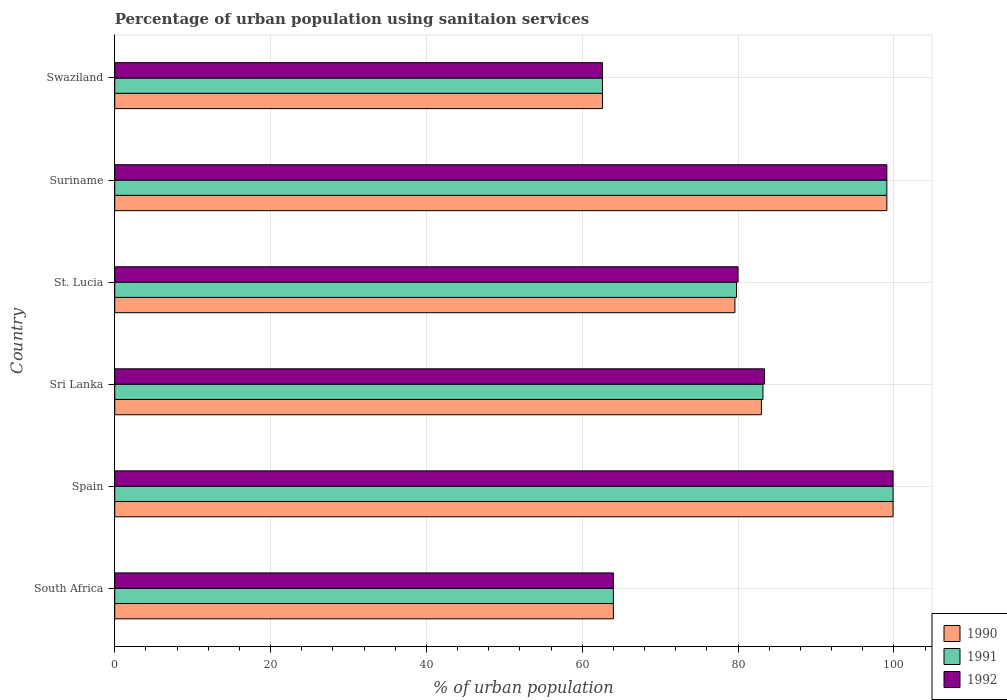How many different coloured bars are there?
Offer a very short reply. 3. Are the number of bars on each tick of the Y-axis equal?
Keep it short and to the point. Yes. What is the label of the 3rd group of bars from the top?
Provide a short and direct response. St. Lucia. What is the percentage of urban population using sanitaion services in 1991 in Suriname?
Your answer should be very brief. 99.1. Across all countries, what is the maximum percentage of urban population using sanitaion services in 1991?
Make the answer very short. 99.9. Across all countries, what is the minimum percentage of urban population using sanitaion services in 1991?
Your answer should be very brief. 62.6. In which country was the percentage of urban population using sanitaion services in 1992 minimum?
Give a very brief answer. Swaziland. What is the total percentage of urban population using sanitaion services in 1992 in the graph?
Offer a terse response. 489. What is the difference between the percentage of urban population using sanitaion services in 1990 in Spain and that in Sri Lanka?
Provide a short and direct response. 16.9. What is the difference between the percentage of urban population using sanitaion services in 1990 in Sri Lanka and the percentage of urban population using sanitaion services in 1992 in Spain?
Offer a very short reply. -16.9. What is the average percentage of urban population using sanitaion services in 1990 per country?
Offer a very short reply. 81.37. What is the difference between the percentage of urban population using sanitaion services in 1992 and percentage of urban population using sanitaion services in 1991 in Swaziland?
Offer a very short reply. 0. In how many countries, is the percentage of urban population using sanitaion services in 1991 greater than 44 %?
Make the answer very short. 6. What is the ratio of the percentage of urban population using sanitaion services in 1991 in South Africa to that in St. Lucia?
Your answer should be compact. 0.8. Is the percentage of urban population using sanitaion services in 1992 in Spain less than that in Suriname?
Your answer should be compact. No. Is the difference between the percentage of urban population using sanitaion services in 1992 in Suriname and Swaziland greater than the difference between the percentage of urban population using sanitaion services in 1991 in Suriname and Swaziland?
Your answer should be compact. No. What is the difference between the highest and the second highest percentage of urban population using sanitaion services in 1991?
Your answer should be very brief. 0.8. What is the difference between the highest and the lowest percentage of urban population using sanitaion services in 1992?
Ensure brevity in your answer.  37.3. Is the sum of the percentage of urban population using sanitaion services in 1990 in St. Lucia and Swaziland greater than the maximum percentage of urban population using sanitaion services in 1991 across all countries?
Provide a short and direct response. Yes. Are all the bars in the graph horizontal?
Your response must be concise. Yes. How many countries are there in the graph?
Make the answer very short. 6. Does the graph contain grids?
Provide a short and direct response. Yes. Where does the legend appear in the graph?
Keep it short and to the point. Bottom right. How are the legend labels stacked?
Give a very brief answer. Vertical. What is the title of the graph?
Keep it short and to the point. Percentage of urban population using sanitaion services. What is the label or title of the X-axis?
Your answer should be very brief. % of urban population. What is the label or title of the Y-axis?
Provide a short and direct response. Country. What is the % of urban population in 1990 in South Africa?
Keep it short and to the point. 64. What is the % of urban population in 1990 in Spain?
Ensure brevity in your answer.  99.9. What is the % of urban population in 1991 in Spain?
Your answer should be compact. 99.9. What is the % of urban population of 1992 in Spain?
Your response must be concise. 99.9. What is the % of urban population of 1990 in Sri Lanka?
Provide a short and direct response. 83. What is the % of urban population of 1991 in Sri Lanka?
Make the answer very short. 83.2. What is the % of urban population in 1992 in Sri Lanka?
Provide a succinct answer. 83.4. What is the % of urban population in 1990 in St. Lucia?
Provide a succinct answer. 79.6. What is the % of urban population in 1991 in St. Lucia?
Make the answer very short. 79.8. What is the % of urban population in 1992 in St. Lucia?
Your answer should be very brief. 80. What is the % of urban population in 1990 in Suriname?
Offer a terse response. 99.1. What is the % of urban population in 1991 in Suriname?
Keep it short and to the point. 99.1. What is the % of urban population in 1992 in Suriname?
Provide a short and direct response. 99.1. What is the % of urban population in 1990 in Swaziland?
Make the answer very short. 62.6. What is the % of urban population in 1991 in Swaziland?
Offer a terse response. 62.6. What is the % of urban population of 1992 in Swaziland?
Offer a terse response. 62.6. Across all countries, what is the maximum % of urban population of 1990?
Provide a succinct answer. 99.9. Across all countries, what is the maximum % of urban population of 1991?
Provide a succinct answer. 99.9. Across all countries, what is the maximum % of urban population in 1992?
Provide a succinct answer. 99.9. Across all countries, what is the minimum % of urban population in 1990?
Offer a terse response. 62.6. Across all countries, what is the minimum % of urban population in 1991?
Your answer should be compact. 62.6. Across all countries, what is the minimum % of urban population in 1992?
Your answer should be compact. 62.6. What is the total % of urban population in 1990 in the graph?
Give a very brief answer. 488.2. What is the total % of urban population in 1991 in the graph?
Ensure brevity in your answer.  488.6. What is the total % of urban population of 1992 in the graph?
Provide a succinct answer. 489. What is the difference between the % of urban population of 1990 in South Africa and that in Spain?
Provide a short and direct response. -35.9. What is the difference between the % of urban population of 1991 in South Africa and that in Spain?
Give a very brief answer. -35.9. What is the difference between the % of urban population in 1992 in South Africa and that in Spain?
Your answer should be compact. -35.9. What is the difference between the % of urban population in 1991 in South Africa and that in Sri Lanka?
Your answer should be very brief. -19.2. What is the difference between the % of urban population of 1992 in South Africa and that in Sri Lanka?
Make the answer very short. -19.4. What is the difference between the % of urban population in 1990 in South Africa and that in St. Lucia?
Make the answer very short. -15.6. What is the difference between the % of urban population in 1991 in South Africa and that in St. Lucia?
Your answer should be very brief. -15.8. What is the difference between the % of urban population of 1990 in South Africa and that in Suriname?
Offer a very short reply. -35.1. What is the difference between the % of urban population in 1991 in South Africa and that in Suriname?
Keep it short and to the point. -35.1. What is the difference between the % of urban population of 1992 in South Africa and that in Suriname?
Offer a terse response. -35.1. What is the difference between the % of urban population of 1990 in South Africa and that in Swaziland?
Offer a terse response. 1.4. What is the difference between the % of urban population of 1991 in South Africa and that in Swaziland?
Keep it short and to the point. 1.4. What is the difference between the % of urban population in 1991 in Spain and that in Sri Lanka?
Ensure brevity in your answer.  16.7. What is the difference between the % of urban population in 1990 in Spain and that in St. Lucia?
Your answer should be compact. 20.3. What is the difference between the % of urban population of 1991 in Spain and that in St. Lucia?
Keep it short and to the point. 20.1. What is the difference between the % of urban population in 1992 in Spain and that in St. Lucia?
Offer a very short reply. 19.9. What is the difference between the % of urban population of 1991 in Spain and that in Suriname?
Keep it short and to the point. 0.8. What is the difference between the % of urban population of 1992 in Spain and that in Suriname?
Give a very brief answer. 0.8. What is the difference between the % of urban population in 1990 in Spain and that in Swaziland?
Offer a terse response. 37.3. What is the difference between the % of urban population in 1991 in Spain and that in Swaziland?
Your answer should be compact. 37.3. What is the difference between the % of urban population of 1992 in Spain and that in Swaziland?
Give a very brief answer. 37.3. What is the difference between the % of urban population in 1992 in Sri Lanka and that in St. Lucia?
Provide a short and direct response. 3.4. What is the difference between the % of urban population in 1990 in Sri Lanka and that in Suriname?
Provide a succinct answer. -16.1. What is the difference between the % of urban population in 1991 in Sri Lanka and that in Suriname?
Provide a succinct answer. -15.9. What is the difference between the % of urban population in 1992 in Sri Lanka and that in Suriname?
Offer a very short reply. -15.7. What is the difference between the % of urban population in 1990 in Sri Lanka and that in Swaziland?
Offer a very short reply. 20.4. What is the difference between the % of urban population in 1991 in Sri Lanka and that in Swaziland?
Give a very brief answer. 20.6. What is the difference between the % of urban population in 1992 in Sri Lanka and that in Swaziland?
Make the answer very short. 20.8. What is the difference between the % of urban population in 1990 in St. Lucia and that in Suriname?
Keep it short and to the point. -19.5. What is the difference between the % of urban population in 1991 in St. Lucia and that in Suriname?
Provide a short and direct response. -19.3. What is the difference between the % of urban population in 1992 in St. Lucia and that in Suriname?
Your answer should be very brief. -19.1. What is the difference between the % of urban population in 1990 in St. Lucia and that in Swaziland?
Your answer should be compact. 17. What is the difference between the % of urban population in 1991 in St. Lucia and that in Swaziland?
Provide a succinct answer. 17.2. What is the difference between the % of urban population of 1990 in Suriname and that in Swaziland?
Your response must be concise. 36.5. What is the difference between the % of urban population in 1991 in Suriname and that in Swaziland?
Provide a short and direct response. 36.5. What is the difference between the % of urban population in 1992 in Suriname and that in Swaziland?
Your answer should be very brief. 36.5. What is the difference between the % of urban population in 1990 in South Africa and the % of urban population in 1991 in Spain?
Provide a short and direct response. -35.9. What is the difference between the % of urban population of 1990 in South Africa and the % of urban population of 1992 in Spain?
Give a very brief answer. -35.9. What is the difference between the % of urban population in 1991 in South Africa and the % of urban population in 1992 in Spain?
Ensure brevity in your answer.  -35.9. What is the difference between the % of urban population of 1990 in South Africa and the % of urban population of 1991 in Sri Lanka?
Offer a terse response. -19.2. What is the difference between the % of urban population of 1990 in South Africa and the % of urban population of 1992 in Sri Lanka?
Your response must be concise. -19.4. What is the difference between the % of urban population in 1991 in South Africa and the % of urban population in 1992 in Sri Lanka?
Ensure brevity in your answer.  -19.4. What is the difference between the % of urban population of 1990 in South Africa and the % of urban population of 1991 in St. Lucia?
Give a very brief answer. -15.8. What is the difference between the % of urban population of 1990 in South Africa and the % of urban population of 1992 in St. Lucia?
Provide a succinct answer. -16. What is the difference between the % of urban population in 1991 in South Africa and the % of urban population in 1992 in St. Lucia?
Keep it short and to the point. -16. What is the difference between the % of urban population of 1990 in South Africa and the % of urban population of 1991 in Suriname?
Ensure brevity in your answer.  -35.1. What is the difference between the % of urban population in 1990 in South Africa and the % of urban population in 1992 in Suriname?
Give a very brief answer. -35.1. What is the difference between the % of urban population in 1991 in South Africa and the % of urban population in 1992 in Suriname?
Your response must be concise. -35.1. What is the difference between the % of urban population in 1990 in South Africa and the % of urban population in 1991 in Swaziland?
Provide a succinct answer. 1.4. What is the difference between the % of urban population in 1991 in South Africa and the % of urban population in 1992 in Swaziland?
Keep it short and to the point. 1.4. What is the difference between the % of urban population of 1990 in Spain and the % of urban population of 1991 in Sri Lanka?
Make the answer very short. 16.7. What is the difference between the % of urban population in 1990 in Spain and the % of urban population in 1992 in Sri Lanka?
Provide a short and direct response. 16.5. What is the difference between the % of urban population of 1990 in Spain and the % of urban population of 1991 in St. Lucia?
Keep it short and to the point. 20.1. What is the difference between the % of urban population of 1990 in Spain and the % of urban population of 1991 in Suriname?
Offer a terse response. 0.8. What is the difference between the % of urban population of 1990 in Spain and the % of urban population of 1991 in Swaziland?
Make the answer very short. 37.3. What is the difference between the % of urban population in 1990 in Spain and the % of urban population in 1992 in Swaziland?
Your answer should be very brief. 37.3. What is the difference between the % of urban population of 1991 in Spain and the % of urban population of 1992 in Swaziland?
Your response must be concise. 37.3. What is the difference between the % of urban population of 1990 in Sri Lanka and the % of urban population of 1991 in St. Lucia?
Your answer should be compact. 3.2. What is the difference between the % of urban population in 1991 in Sri Lanka and the % of urban population in 1992 in St. Lucia?
Give a very brief answer. 3.2. What is the difference between the % of urban population of 1990 in Sri Lanka and the % of urban population of 1991 in Suriname?
Give a very brief answer. -16.1. What is the difference between the % of urban population of 1990 in Sri Lanka and the % of urban population of 1992 in Suriname?
Make the answer very short. -16.1. What is the difference between the % of urban population in 1991 in Sri Lanka and the % of urban population in 1992 in Suriname?
Offer a terse response. -15.9. What is the difference between the % of urban population in 1990 in Sri Lanka and the % of urban population in 1991 in Swaziland?
Make the answer very short. 20.4. What is the difference between the % of urban population in 1990 in Sri Lanka and the % of urban population in 1992 in Swaziland?
Make the answer very short. 20.4. What is the difference between the % of urban population of 1991 in Sri Lanka and the % of urban population of 1992 in Swaziland?
Provide a succinct answer. 20.6. What is the difference between the % of urban population of 1990 in St. Lucia and the % of urban population of 1991 in Suriname?
Give a very brief answer. -19.5. What is the difference between the % of urban population of 1990 in St. Lucia and the % of urban population of 1992 in Suriname?
Provide a short and direct response. -19.5. What is the difference between the % of urban population of 1991 in St. Lucia and the % of urban population of 1992 in Suriname?
Make the answer very short. -19.3. What is the difference between the % of urban population of 1990 in St. Lucia and the % of urban population of 1991 in Swaziland?
Offer a very short reply. 17. What is the difference between the % of urban population in 1991 in St. Lucia and the % of urban population in 1992 in Swaziland?
Make the answer very short. 17.2. What is the difference between the % of urban population in 1990 in Suriname and the % of urban population in 1991 in Swaziland?
Offer a very short reply. 36.5. What is the difference between the % of urban population of 1990 in Suriname and the % of urban population of 1992 in Swaziland?
Provide a short and direct response. 36.5. What is the difference between the % of urban population in 1991 in Suriname and the % of urban population in 1992 in Swaziland?
Ensure brevity in your answer.  36.5. What is the average % of urban population in 1990 per country?
Make the answer very short. 81.37. What is the average % of urban population of 1991 per country?
Your response must be concise. 81.43. What is the average % of urban population in 1992 per country?
Provide a short and direct response. 81.5. What is the difference between the % of urban population of 1990 and % of urban population of 1992 in South Africa?
Provide a succinct answer. 0. What is the difference between the % of urban population of 1991 and % of urban population of 1992 in South Africa?
Provide a succinct answer. 0. What is the difference between the % of urban population of 1990 and % of urban population of 1991 in Spain?
Offer a terse response. 0. What is the difference between the % of urban population of 1991 and % of urban population of 1992 in Spain?
Offer a very short reply. 0. What is the difference between the % of urban population of 1990 and % of urban population of 1991 in Sri Lanka?
Provide a short and direct response. -0.2. What is the difference between the % of urban population in 1990 and % of urban population in 1991 in St. Lucia?
Offer a terse response. -0.2. What is the difference between the % of urban population in 1990 and % of urban population in 1992 in St. Lucia?
Give a very brief answer. -0.4. What is the difference between the % of urban population of 1990 and % of urban population of 1992 in Suriname?
Your answer should be compact. 0. What is the difference between the % of urban population of 1991 and % of urban population of 1992 in Swaziland?
Make the answer very short. 0. What is the ratio of the % of urban population of 1990 in South Africa to that in Spain?
Offer a terse response. 0.64. What is the ratio of the % of urban population of 1991 in South Africa to that in Spain?
Provide a succinct answer. 0.64. What is the ratio of the % of urban population in 1992 in South Africa to that in Spain?
Your answer should be compact. 0.64. What is the ratio of the % of urban population of 1990 in South Africa to that in Sri Lanka?
Keep it short and to the point. 0.77. What is the ratio of the % of urban population in 1991 in South Africa to that in Sri Lanka?
Provide a succinct answer. 0.77. What is the ratio of the % of urban population in 1992 in South Africa to that in Sri Lanka?
Keep it short and to the point. 0.77. What is the ratio of the % of urban population in 1990 in South Africa to that in St. Lucia?
Provide a succinct answer. 0.8. What is the ratio of the % of urban population of 1991 in South Africa to that in St. Lucia?
Your response must be concise. 0.8. What is the ratio of the % of urban population of 1992 in South Africa to that in St. Lucia?
Make the answer very short. 0.8. What is the ratio of the % of urban population of 1990 in South Africa to that in Suriname?
Your answer should be very brief. 0.65. What is the ratio of the % of urban population of 1991 in South Africa to that in Suriname?
Your answer should be very brief. 0.65. What is the ratio of the % of urban population of 1992 in South Africa to that in Suriname?
Your answer should be compact. 0.65. What is the ratio of the % of urban population of 1990 in South Africa to that in Swaziland?
Make the answer very short. 1.02. What is the ratio of the % of urban population of 1991 in South Africa to that in Swaziland?
Offer a very short reply. 1.02. What is the ratio of the % of urban population in 1992 in South Africa to that in Swaziland?
Offer a terse response. 1.02. What is the ratio of the % of urban population in 1990 in Spain to that in Sri Lanka?
Keep it short and to the point. 1.2. What is the ratio of the % of urban population of 1991 in Spain to that in Sri Lanka?
Give a very brief answer. 1.2. What is the ratio of the % of urban population of 1992 in Spain to that in Sri Lanka?
Provide a short and direct response. 1.2. What is the ratio of the % of urban population of 1990 in Spain to that in St. Lucia?
Ensure brevity in your answer.  1.25. What is the ratio of the % of urban population in 1991 in Spain to that in St. Lucia?
Your response must be concise. 1.25. What is the ratio of the % of urban population of 1992 in Spain to that in St. Lucia?
Provide a succinct answer. 1.25. What is the ratio of the % of urban population in 1990 in Spain to that in Swaziland?
Keep it short and to the point. 1.6. What is the ratio of the % of urban population of 1991 in Spain to that in Swaziland?
Your response must be concise. 1.6. What is the ratio of the % of urban population in 1992 in Spain to that in Swaziland?
Keep it short and to the point. 1.6. What is the ratio of the % of urban population of 1990 in Sri Lanka to that in St. Lucia?
Offer a terse response. 1.04. What is the ratio of the % of urban population of 1991 in Sri Lanka to that in St. Lucia?
Offer a terse response. 1.04. What is the ratio of the % of urban population in 1992 in Sri Lanka to that in St. Lucia?
Ensure brevity in your answer.  1.04. What is the ratio of the % of urban population in 1990 in Sri Lanka to that in Suriname?
Give a very brief answer. 0.84. What is the ratio of the % of urban population of 1991 in Sri Lanka to that in Suriname?
Offer a terse response. 0.84. What is the ratio of the % of urban population of 1992 in Sri Lanka to that in Suriname?
Keep it short and to the point. 0.84. What is the ratio of the % of urban population in 1990 in Sri Lanka to that in Swaziland?
Ensure brevity in your answer.  1.33. What is the ratio of the % of urban population in 1991 in Sri Lanka to that in Swaziland?
Offer a very short reply. 1.33. What is the ratio of the % of urban population of 1992 in Sri Lanka to that in Swaziland?
Provide a succinct answer. 1.33. What is the ratio of the % of urban population in 1990 in St. Lucia to that in Suriname?
Your answer should be very brief. 0.8. What is the ratio of the % of urban population of 1991 in St. Lucia to that in Suriname?
Provide a short and direct response. 0.81. What is the ratio of the % of urban population of 1992 in St. Lucia to that in Suriname?
Offer a very short reply. 0.81. What is the ratio of the % of urban population in 1990 in St. Lucia to that in Swaziland?
Provide a succinct answer. 1.27. What is the ratio of the % of urban population in 1991 in St. Lucia to that in Swaziland?
Make the answer very short. 1.27. What is the ratio of the % of urban population in 1992 in St. Lucia to that in Swaziland?
Ensure brevity in your answer.  1.28. What is the ratio of the % of urban population of 1990 in Suriname to that in Swaziland?
Offer a terse response. 1.58. What is the ratio of the % of urban population of 1991 in Suriname to that in Swaziland?
Keep it short and to the point. 1.58. What is the ratio of the % of urban population of 1992 in Suriname to that in Swaziland?
Keep it short and to the point. 1.58. What is the difference between the highest and the second highest % of urban population of 1990?
Offer a very short reply. 0.8. What is the difference between the highest and the second highest % of urban population in 1992?
Make the answer very short. 0.8. What is the difference between the highest and the lowest % of urban population in 1990?
Provide a short and direct response. 37.3. What is the difference between the highest and the lowest % of urban population of 1991?
Keep it short and to the point. 37.3. What is the difference between the highest and the lowest % of urban population in 1992?
Your answer should be compact. 37.3. 